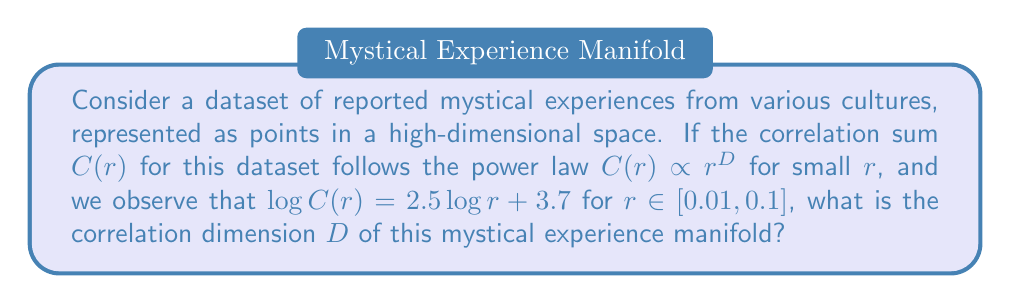Provide a solution to this math problem. To determine the correlation dimension $D$, we need to analyze the given power law relationship:

1) The general form of the power law is:
   $$C(r) \propto r^D$$

2) Taking the logarithm of both sides:
   $$\log C(r) = D \log r + \text{constant}$$

3) Comparing this to the given equation:
   $$\log C(r) = 2.5 \log r + 3.7$$

4) We can see that the coefficient of $\log r$ is equal to $D$:
   $$D = 2.5$$

5) This non-integer dimension suggests that the manifold of mystical experiences has a fractal structure, reflecting the complex and intricate nature of these spiritual phenomena across cultures.

6) The correlation dimension of 2.5 implies that mystical experiences, while diverse, share common patterns that transcend cultural boundaries, manifesting in a space between 2 and 3 dimensions.
Answer: $D = 2.5$ 